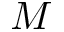Convert formula to latex. <formula><loc_0><loc_0><loc_500><loc_500>M</formula> 